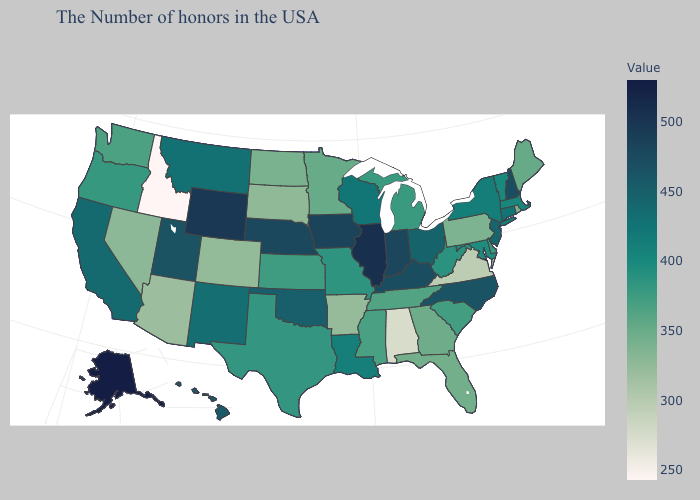Among the states that border Illinois , does Iowa have the highest value?
Answer briefly. Yes. Among the states that border Oregon , which have the lowest value?
Write a very short answer. Idaho. Does Rhode Island have a lower value than New York?
Quick response, please. Yes. Is the legend a continuous bar?
Be succinct. Yes. Is the legend a continuous bar?
Short answer required. Yes. Among the states that border South Dakota , does Iowa have the lowest value?
Give a very brief answer. No. Which states have the lowest value in the Northeast?
Keep it brief. Pennsylvania. Among the states that border Virginia , which have the highest value?
Give a very brief answer. Kentucky. 